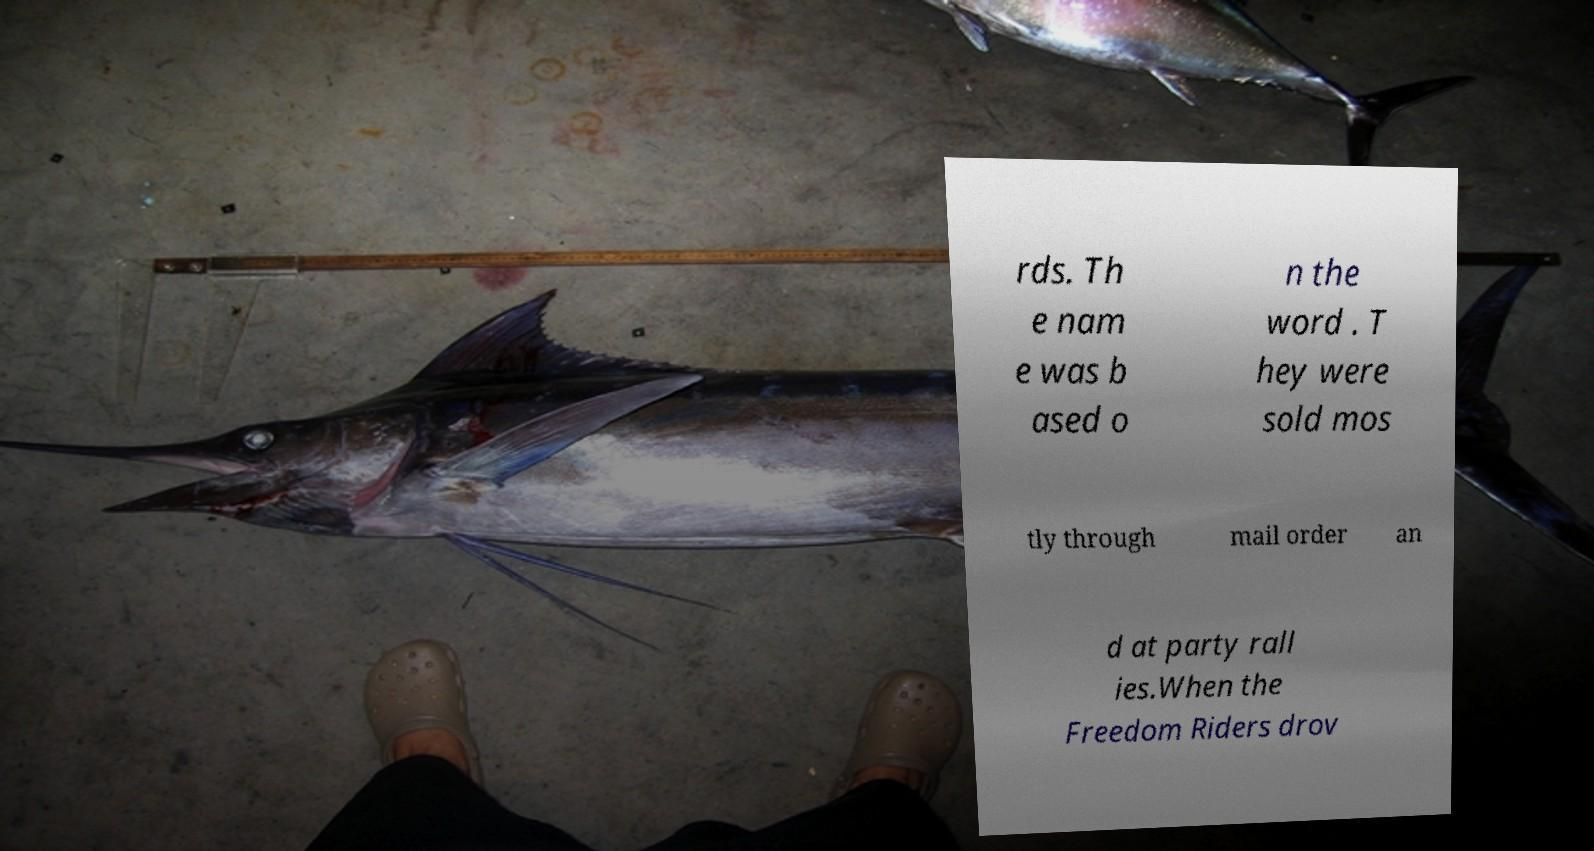Can you accurately transcribe the text from the provided image for me? rds. Th e nam e was b ased o n the word . T hey were sold mos tly through mail order an d at party rall ies.When the Freedom Riders drov 